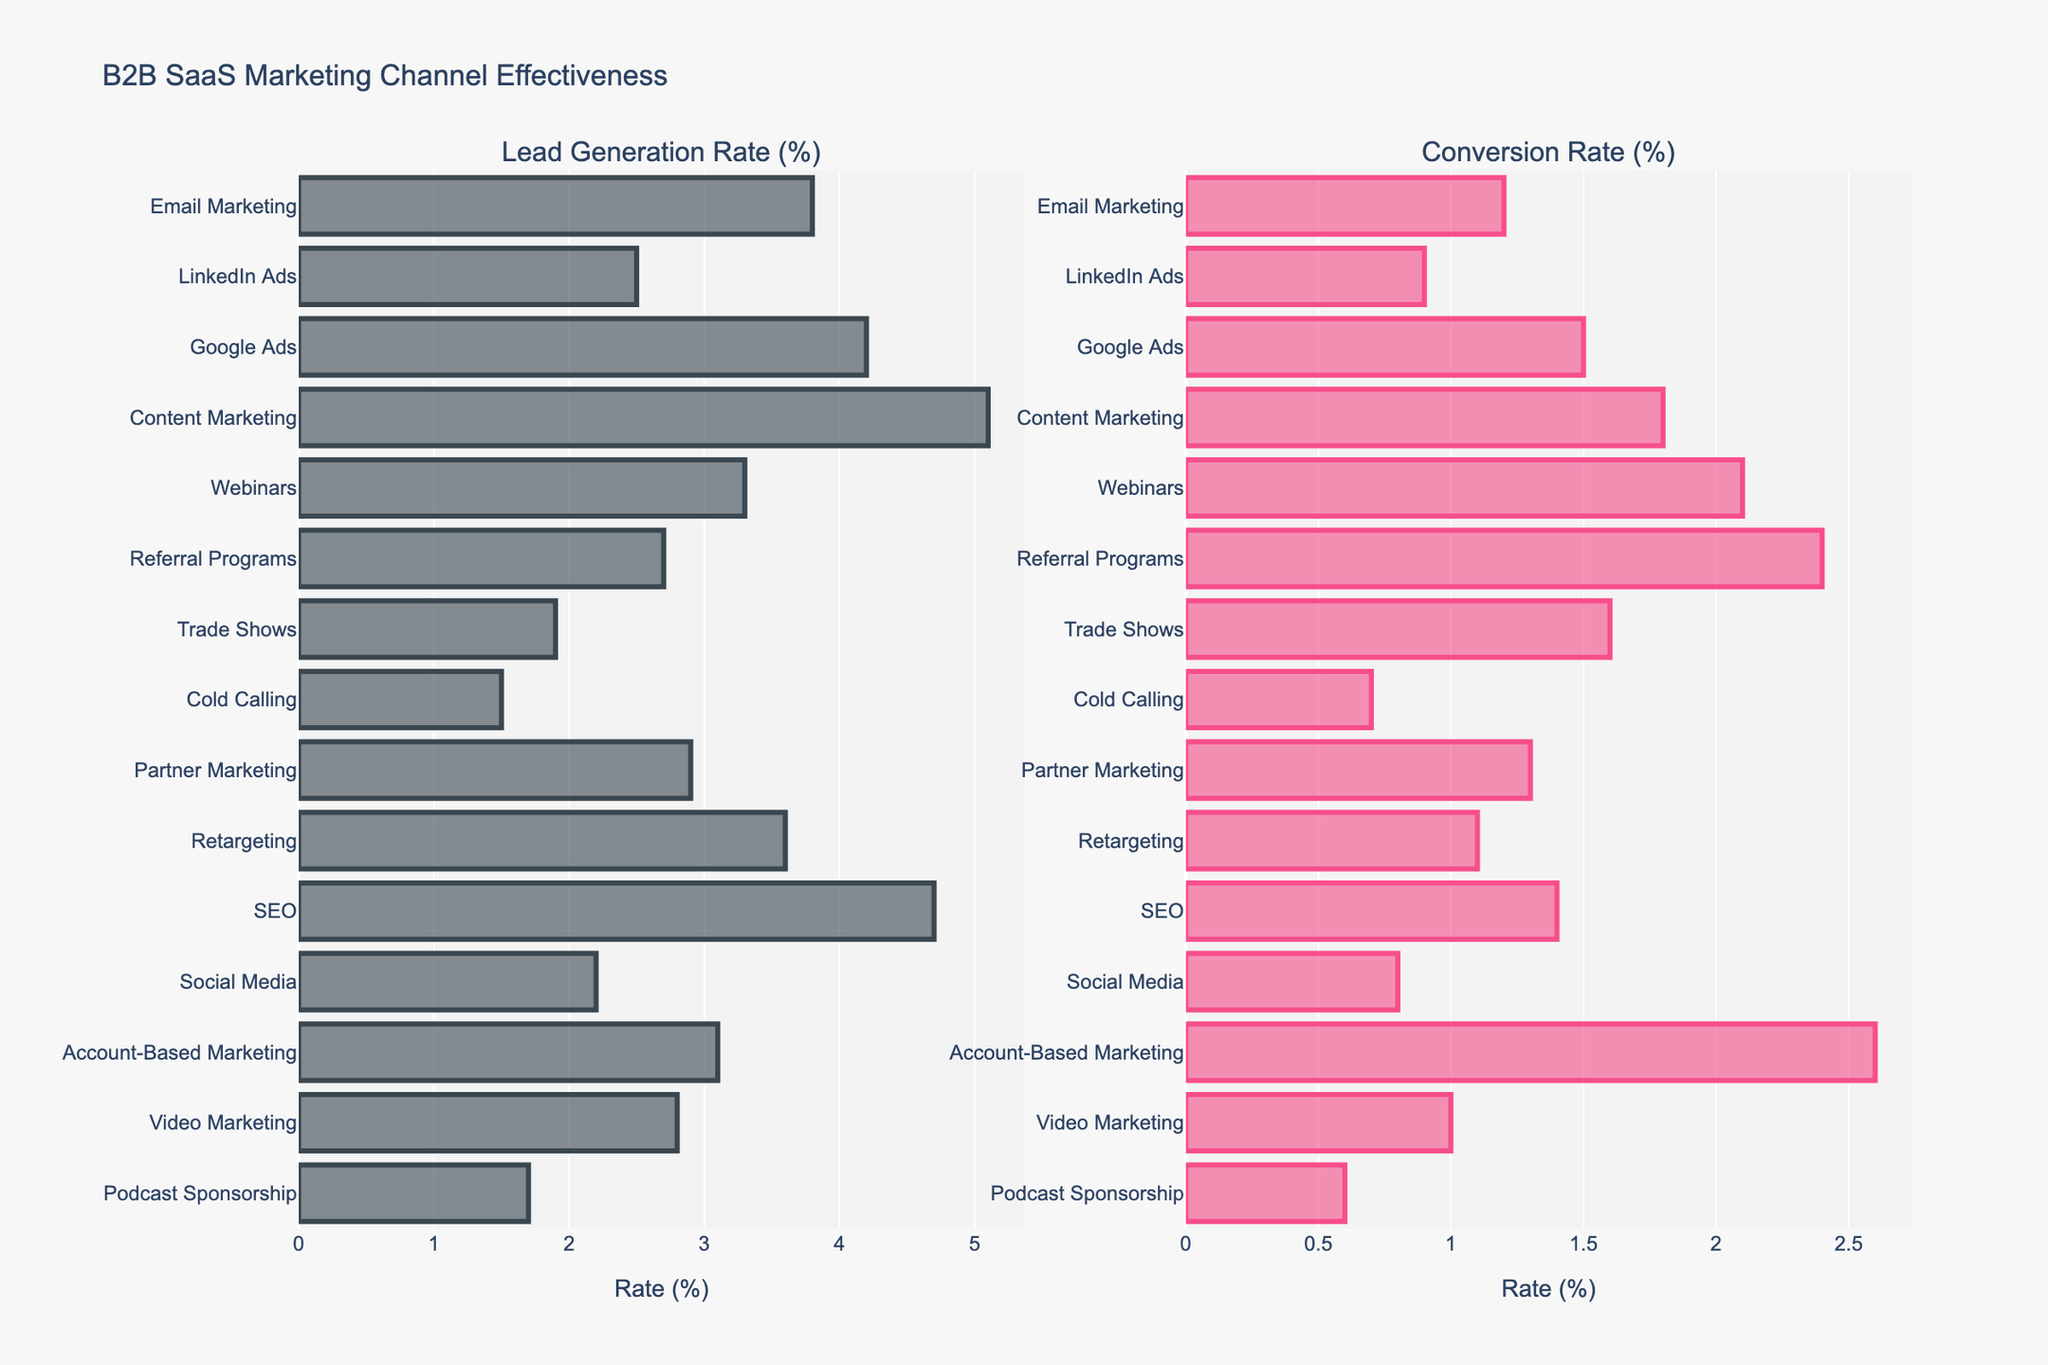What's the channel with the highest lead generation rate? Content Marketing has the highest lead generation rate at 5.1%. You can see that it is the tallest bar in the left subplot for "Lead Generation Rate (%)".
Answer: Content Marketing Which marketing channel has a higher conversion rate, Webinars or Google Ads? Webinars have a conversion rate of 2.1%, while Google Ads have a conversion rate of 1.5%. By comparing the lengths of the two bars in the "Conversion Rate (%)" subplot, it's clear that Webinars' bar is longer.
Answer: Webinars Identify the top three channels for lead generation rates. The top three channels for lead generation rates are Content Marketing (5.1%), SEO (4.7%), and Google Ads (4.2%). This is determined by looking at the three tallest bars in the "Lead Generation Rate (%)" subplot.
Answer: Content Marketing, SEO, Google Ads What is the difference in conversion rates between Account-Based Marketing and Cold Calling? Account-Based Marketing has a conversion rate of 2.6%, and Cold Calling has a conversion rate of 0.7%. The difference can be found by subtracting the Cold Calling rate from the Account-Based Marketing rate (2.6% - 0.7% = 1.9%).
Answer: 1.9% What's the average conversion rate across all marketing channels? Sum of all conversion rates (1.2 + 0.9 + 1.5 + 1.8 + 2.1 + 2.4 + 1.6 + 0.7 + 1.3 + 1.1 + 1.4 + 0.8 + 2.6 + 1.0 + 0.6) = 20.4. There are 15 channels. Average = 20.4 / 15 = 1.36%.
Answer: 1.36% Which marketing channel has the lowest performance in both lead generation and conversion rates? Podcast Sponsorship has the lowest performance in both categories, with a lead generation rate of 1.7% and a conversion rate of 0.6%. By visually inspecting both subplots, Podcast Sponsorship's bars are among the shortest.
Answer: Podcast Sponsorship Compare the lengths of the bars for Trade Shows and Partner Marketing in terms of both lead generation and conversion rates. For lead generation, Trade Shows have a rate of 1.9%, which is shorter than Partner Marketing's 2.9%. For conversion rate, Trade Shows have a rate of 1.6%, while Partner Marketing's rate is 1.3%, making the Trade Shows bar slightly longer in this subplot.
Answer: Lead Generation: Partner Marketing is higher, Conversion Rate: Trade Shows is higher Is the lead generation rate of Video Marketing greater than or equal to the conversion rate of Account-Based Marketing? The lead generation rate for Video Marketing is 2.8%. The conversion rate for Account-Based Marketing is 2.6%. Since 2.8% > 2.6%, the lead generation rate for Video Marketing is greater.
Answer: Yes How much higher is the lead generation rate of SEO compared to Email Marketing? SEO has a lead generation rate of 4.7%, and Email Marketing has a rate of 3.8%. The difference is 4.7% - 3.8% = 0.9%.
Answer: 0.9% What's the median value of conversion rates across all channels? To find the median, first list all conversion rates in ascending order (0.6, 0.7, 0.8, 0.9, 1.0, 1.1, 1.2, 1.3, 1.4, 1.5, 1.6, 1.8, 2.1, 2.4, 2.6). With 15 values, the median is the 8th value in the ordered list, which is 1.3%.
Answer: 1.3% 